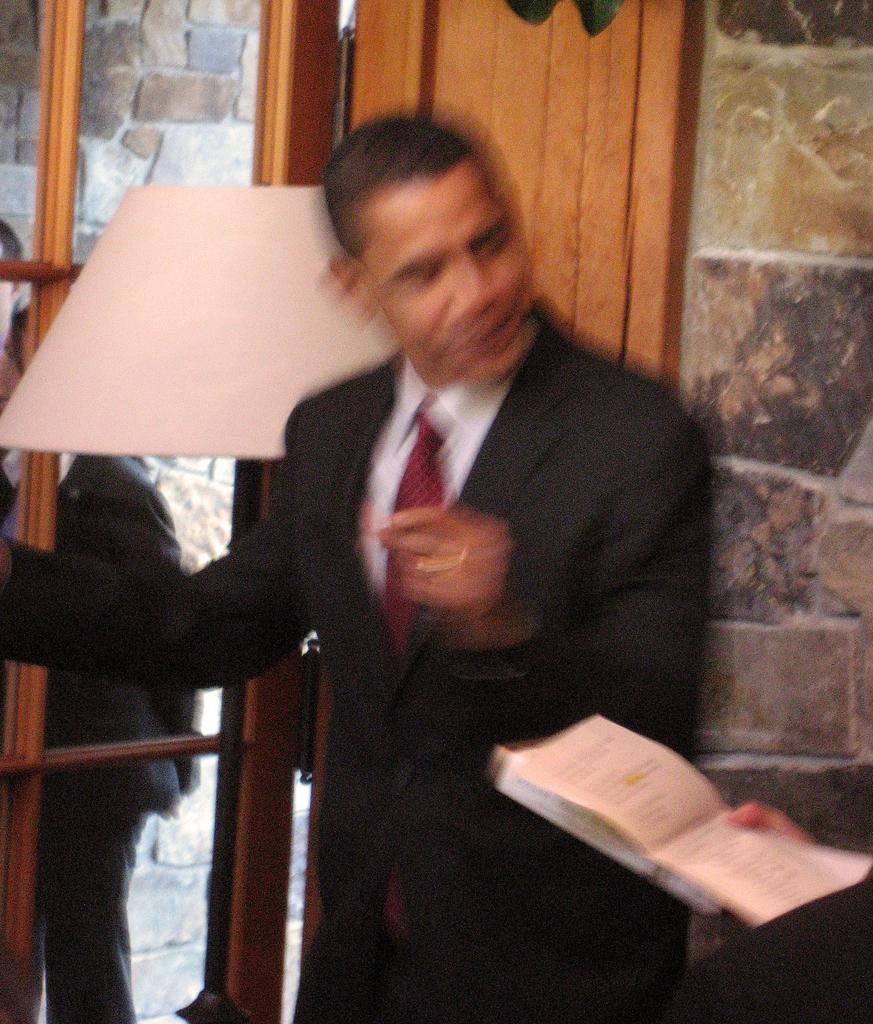What is the main subject of the image? There is a person standing in the image. What is the person holding in the image? There is a person's hand holding a book in the image. What architectural feature can be seen in the image? There is a door in the image. What can be seen through the door in the image? Two persons are visible through the door. What type of background is present in the image? There is a wall in the image. What type of picture is hanging on the wall in the image? There is no picture hanging on the wall in the image; it is a plain wall. What season is depicted in the field visible through the door? There is no field visible through the door in the image, only two persons. 